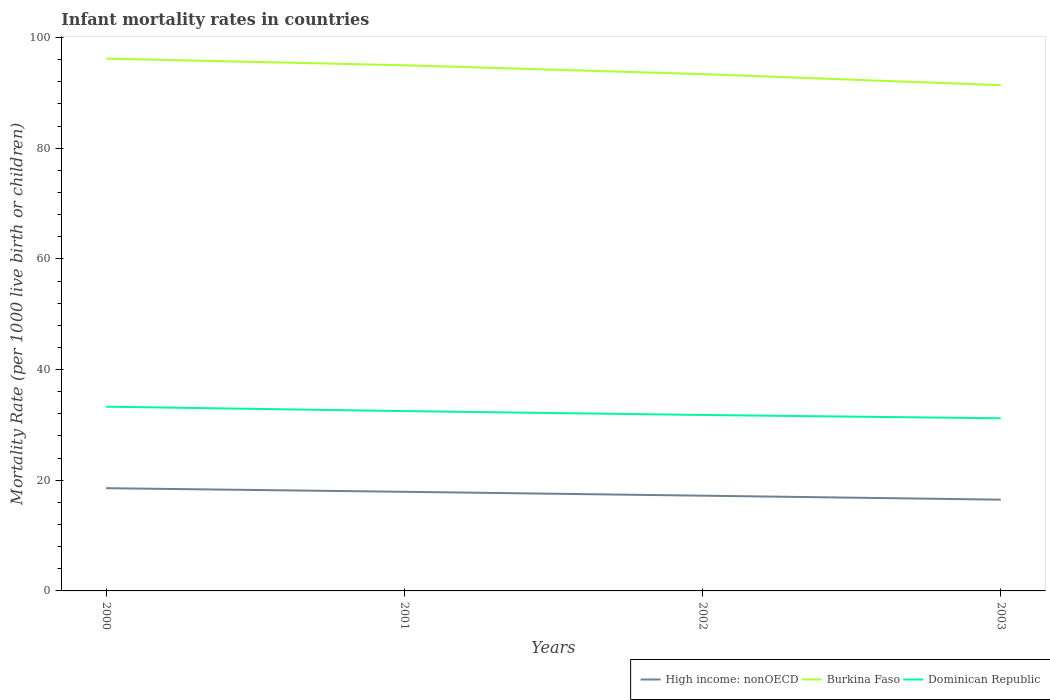How many different coloured lines are there?
Provide a succinct answer. 3. Is the number of lines equal to the number of legend labels?
Your response must be concise. Yes. Across all years, what is the maximum infant mortality rate in Dominican Republic?
Give a very brief answer. 31.2. In which year was the infant mortality rate in High income: nonOECD maximum?
Your answer should be very brief. 2003. What is the total infant mortality rate in Dominican Republic in the graph?
Keep it short and to the point. 1.3. What is the difference between the highest and the second highest infant mortality rate in High income: nonOECD?
Provide a short and direct response. 2.07. Where does the legend appear in the graph?
Provide a short and direct response. Bottom right. How many legend labels are there?
Offer a terse response. 3. How are the legend labels stacked?
Your answer should be compact. Horizontal. What is the title of the graph?
Your answer should be compact. Infant mortality rates in countries. Does "Europe(all income levels)" appear as one of the legend labels in the graph?
Your response must be concise. No. What is the label or title of the X-axis?
Your response must be concise. Years. What is the label or title of the Y-axis?
Your response must be concise. Mortality Rate (per 1000 live birth or children). What is the Mortality Rate (per 1000 live birth or children) in High income: nonOECD in 2000?
Make the answer very short. 18.57. What is the Mortality Rate (per 1000 live birth or children) of Burkina Faso in 2000?
Provide a succinct answer. 96.2. What is the Mortality Rate (per 1000 live birth or children) of Dominican Republic in 2000?
Make the answer very short. 33.3. What is the Mortality Rate (per 1000 live birth or children) of High income: nonOECD in 2001?
Offer a very short reply. 17.92. What is the Mortality Rate (per 1000 live birth or children) in Burkina Faso in 2001?
Ensure brevity in your answer.  95. What is the Mortality Rate (per 1000 live birth or children) in Dominican Republic in 2001?
Offer a very short reply. 32.5. What is the Mortality Rate (per 1000 live birth or children) of High income: nonOECD in 2002?
Offer a very short reply. 17.21. What is the Mortality Rate (per 1000 live birth or children) of Burkina Faso in 2002?
Give a very brief answer. 93.4. What is the Mortality Rate (per 1000 live birth or children) in Dominican Republic in 2002?
Provide a succinct answer. 31.8. What is the Mortality Rate (per 1000 live birth or children) of High income: nonOECD in 2003?
Your answer should be very brief. 16.49. What is the Mortality Rate (per 1000 live birth or children) in Burkina Faso in 2003?
Your answer should be very brief. 91.4. What is the Mortality Rate (per 1000 live birth or children) in Dominican Republic in 2003?
Keep it short and to the point. 31.2. Across all years, what is the maximum Mortality Rate (per 1000 live birth or children) of High income: nonOECD?
Offer a very short reply. 18.57. Across all years, what is the maximum Mortality Rate (per 1000 live birth or children) of Burkina Faso?
Provide a short and direct response. 96.2. Across all years, what is the maximum Mortality Rate (per 1000 live birth or children) in Dominican Republic?
Offer a terse response. 33.3. Across all years, what is the minimum Mortality Rate (per 1000 live birth or children) of High income: nonOECD?
Give a very brief answer. 16.49. Across all years, what is the minimum Mortality Rate (per 1000 live birth or children) in Burkina Faso?
Give a very brief answer. 91.4. Across all years, what is the minimum Mortality Rate (per 1000 live birth or children) of Dominican Republic?
Your response must be concise. 31.2. What is the total Mortality Rate (per 1000 live birth or children) of High income: nonOECD in the graph?
Provide a short and direct response. 70.19. What is the total Mortality Rate (per 1000 live birth or children) in Burkina Faso in the graph?
Ensure brevity in your answer.  376. What is the total Mortality Rate (per 1000 live birth or children) in Dominican Republic in the graph?
Offer a very short reply. 128.8. What is the difference between the Mortality Rate (per 1000 live birth or children) in High income: nonOECD in 2000 and that in 2001?
Provide a short and direct response. 0.65. What is the difference between the Mortality Rate (per 1000 live birth or children) of Dominican Republic in 2000 and that in 2001?
Provide a short and direct response. 0.8. What is the difference between the Mortality Rate (per 1000 live birth or children) of High income: nonOECD in 2000 and that in 2002?
Give a very brief answer. 1.35. What is the difference between the Mortality Rate (per 1000 live birth or children) in Burkina Faso in 2000 and that in 2002?
Give a very brief answer. 2.8. What is the difference between the Mortality Rate (per 1000 live birth or children) of Dominican Republic in 2000 and that in 2002?
Your answer should be very brief. 1.5. What is the difference between the Mortality Rate (per 1000 live birth or children) of High income: nonOECD in 2000 and that in 2003?
Give a very brief answer. 2.07. What is the difference between the Mortality Rate (per 1000 live birth or children) of Burkina Faso in 2000 and that in 2003?
Your response must be concise. 4.8. What is the difference between the Mortality Rate (per 1000 live birth or children) of Dominican Republic in 2000 and that in 2003?
Give a very brief answer. 2.1. What is the difference between the Mortality Rate (per 1000 live birth or children) of High income: nonOECD in 2001 and that in 2002?
Provide a succinct answer. 0.7. What is the difference between the Mortality Rate (per 1000 live birth or children) in Burkina Faso in 2001 and that in 2002?
Offer a very short reply. 1.6. What is the difference between the Mortality Rate (per 1000 live birth or children) of Dominican Republic in 2001 and that in 2002?
Give a very brief answer. 0.7. What is the difference between the Mortality Rate (per 1000 live birth or children) of High income: nonOECD in 2001 and that in 2003?
Ensure brevity in your answer.  1.42. What is the difference between the Mortality Rate (per 1000 live birth or children) in Dominican Republic in 2001 and that in 2003?
Offer a terse response. 1.3. What is the difference between the Mortality Rate (per 1000 live birth or children) in High income: nonOECD in 2002 and that in 2003?
Your response must be concise. 0.72. What is the difference between the Mortality Rate (per 1000 live birth or children) in Dominican Republic in 2002 and that in 2003?
Your answer should be very brief. 0.6. What is the difference between the Mortality Rate (per 1000 live birth or children) in High income: nonOECD in 2000 and the Mortality Rate (per 1000 live birth or children) in Burkina Faso in 2001?
Give a very brief answer. -76.43. What is the difference between the Mortality Rate (per 1000 live birth or children) in High income: nonOECD in 2000 and the Mortality Rate (per 1000 live birth or children) in Dominican Republic in 2001?
Keep it short and to the point. -13.93. What is the difference between the Mortality Rate (per 1000 live birth or children) in Burkina Faso in 2000 and the Mortality Rate (per 1000 live birth or children) in Dominican Republic in 2001?
Offer a very short reply. 63.7. What is the difference between the Mortality Rate (per 1000 live birth or children) in High income: nonOECD in 2000 and the Mortality Rate (per 1000 live birth or children) in Burkina Faso in 2002?
Your response must be concise. -74.83. What is the difference between the Mortality Rate (per 1000 live birth or children) of High income: nonOECD in 2000 and the Mortality Rate (per 1000 live birth or children) of Dominican Republic in 2002?
Provide a succinct answer. -13.23. What is the difference between the Mortality Rate (per 1000 live birth or children) in Burkina Faso in 2000 and the Mortality Rate (per 1000 live birth or children) in Dominican Republic in 2002?
Your response must be concise. 64.4. What is the difference between the Mortality Rate (per 1000 live birth or children) of High income: nonOECD in 2000 and the Mortality Rate (per 1000 live birth or children) of Burkina Faso in 2003?
Make the answer very short. -72.83. What is the difference between the Mortality Rate (per 1000 live birth or children) of High income: nonOECD in 2000 and the Mortality Rate (per 1000 live birth or children) of Dominican Republic in 2003?
Your response must be concise. -12.63. What is the difference between the Mortality Rate (per 1000 live birth or children) of Burkina Faso in 2000 and the Mortality Rate (per 1000 live birth or children) of Dominican Republic in 2003?
Your response must be concise. 65. What is the difference between the Mortality Rate (per 1000 live birth or children) in High income: nonOECD in 2001 and the Mortality Rate (per 1000 live birth or children) in Burkina Faso in 2002?
Keep it short and to the point. -75.48. What is the difference between the Mortality Rate (per 1000 live birth or children) in High income: nonOECD in 2001 and the Mortality Rate (per 1000 live birth or children) in Dominican Republic in 2002?
Make the answer very short. -13.88. What is the difference between the Mortality Rate (per 1000 live birth or children) of Burkina Faso in 2001 and the Mortality Rate (per 1000 live birth or children) of Dominican Republic in 2002?
Your answer should be compact. 63.2. What is the difference between the Mortality Rate (per 1000 live birth or children) of High income: nonOECD in 2001 and the Mortality Rate (per 1000 live birth or children) of Burkina Faso in 2003?
Your answer should be compact. -73.48. What is the difference between the Mortality Rate (per 1000 live birth or children) of High income: nonOECD in 2001 and the Mortality Rate (per 1000 live birth or children) of Dominican Republic in 2003?
Provide a succinct answer. -13.28. What is the difference between the Mortality Rate (per 1000 live birth or children) in Burkina Faso in 2001 and the Mortality Rate (per 1000 live birth or children) in Dominican Republic in 2003?
Your response must be concise. 63.8. What is the difference between the Mortality Rate (per 1000 live birth or children) in High income: nonOECD in 2002 and the Mortality Rate (per 1000 live birth or children) in Burkina Faso in 2003?
Make the answer very short. -74.19. What is the difference between the Mortality Rate (per 1000 live birth or children) in High income: nonOECD in 2002 and the Mortality Rate (per 1000 live birth or children) in Dominican Republic in 2003?
Your response must be concise. -13.99. What is the difference between the Mortality Rate (per 1000 live birth or children) of Burkina Faso in 2002 and the Mortality Rate (per 1000 live birth or children) of Dominican Republic in 2003?
Your answer should be compact. 62.2. What is the average Mortality Rate (per 1000 live birth or children) in High income: nonOECD per year?
Offer a very short reply. 17.55. What is the average Mortality Rate (per 1000 live birth or children) in Burkina Faso per year?
Provide a succinct answer. 94. What is the average Mortality Rate (per 1000 live birth or children) of Dominican Republic per year?
Offer a terse response. 32.2. In the year 2000, what is the difference between the Mortality Rate (per 1000 live birth or children) of High income: nonOECD and Mortality Rate (per 1000 live birth or children) of Burkina Faso?
Your response must be concise. -77.63. In the year 2000, what is the difference between the Mortality Rate (per 1000 live birth or children) in High income: nonOECD and Mortality Rate (per 1000 live birth or children) in Dominican Republic?
Provide a succinct answer. -14.73. In the year 2000, what is the difference between the Mortality Rate (per 1000 live birth or children) in Burkina Faso and Mortality Rate (per 1000 live birth or children) in Dominican Republic?
Provide a succinct answer. 62.9. In the year 2001, what is the difference between the Mortality Rate (per 1000 live birth or children) of High income: nonOECD and Mortality Rate (per 1000 live birth or children) of Burkina Faso?
Your response must be concise. -77.08. In the year 2001, what is the difference between the Mortality Rate (per 1000 live birth or children) of High income: nonOECD and Mortality Rate (per 1000 live birth or children) of Dominican Republic?
Provide a short and direct response. -14.58. In the year 2001, what is the difference between the Mortality Rate (per 1000 live birth or children) in Burkina Faso and Mortality Rate (per 1000 live birth or children) in Dominican Republic?
Keep it short and to the point. 62.5. In the year 2002, what is the difference between the Mortality Rate (per 1000 live birth or children) of High income: nonOECD and Mortality Rate (per 1000 live birth or children) of Burkina Faso?
Offer a terse response. -76.19. In the year 2002, what is the difference between the Mortality Rate (per 1000 live birth or children) of High income: nonOECD and Mortality Rate (per 1000 live birth or children) of Dominican Republic?
Provide a succinct answer. -14.59. In the year 2002, what is the difference between the Mortality Rate (per 1000 live birth or children) in Burkina Faso and Mortality Rate (per 1000 live birth or children) in Dominican Republic?
Your answer should be compact. 61.6. In the year 2003, what is the difference between the Mortality Rate (per 1000 live birth or children) in High income: nonOECD and Mortality Rate (per 1000 live birth or children) in Burkina Faso?
Make the answer very short. -74.91. In the year 2003, what is the difference between the Mortality Rate (per 1000 live birth or children) in High income: nonOECD and Mortality Rate (per 1000 live birth or children) in Dominican Republic?
Keep it short and to the point. -14.71. In the year 2003, what is the difference between the Mortality Rate (per 1000 live birth or children) of Burkina Faso and Mortality Rate (per 1000 live birth or children) of Dominican Republic?
Offer a terse response. 60.2. What is the ratio of the Mortality Rate (per 1000 live birth or children) of High income: nonOECD in 2000 to that in 2001?
Your answer should be very brief. 1.04. What is the ratio of the Mortality Rate (per 1000 live birth or children) of Burkina Faso in 2000 to that in 2001?
Provide a short and direct response. 1.01. What is the ratio of the Mortality Rate (per 1000 live birth or children) in Dominican Republic in 2000 to that in 2001?
Your response must be concise. 1.02. What is the ratio of the Mortality Rate (per 1000 live birth or children) in High income: nonOECD in 2000 to that in 2002?
Your answer should be compact. 1.08. What is the ratio of the Mortality Rate (per 1000 live birth or children) of Burkina Faso in 2000 to that in 2002?
Provide a short and direct response. 1.03. What is the ratio of the Mortality Rate (per 1000 live birth or children) of Dominican Republic in 2000 to that in 2002?
Make the answer very short. 1.05. What is the ratio of the Mortality Rate (per 1000 live birth or children) of High income: nonOECD in 2000 to that in 2003?
Give a very brief answer. 1.13. What is the ratio of the Mortality Rate (per 1000 live birth or children) in Burkina Faso in 2000 to that in 2003?
Offer a terse response. 1.05. What is the ratio of the Mortality Rate (per 1000 live birth or children) in Dominican Republic in 2000 to that in 2003?
Keep it short and to the point. 1.07. What is the ratio of the Mortality Rate (per 1000 live birth or children) in High income: nonOECD in 2001 to that in 2002?
Ensure brevity in your answer.  1.04. What is the ratio of the Mortality Rate (per 1000 live birth or children) of Burkina Faso in 2001 to that in 2002?
Ensure brevity in your answer.  1.02. What is the ratio of the Mortality Rate (per 1000 live birth or children) in High income: nonOECD in 2001 to that in 2003?
Keep it short and to the point. 1.09. What is the ratio of the Mortality Rate (per 1000 live birth or children) of Burkina Faso in 2001 to that in 2003?
Provide a short and direct response. 1.04. What is the ratio of the Mortality Rate (per 1000 live birth or children) of Dominican Republic in 2001 to that in 2003?
Provide a succinct answer. 1.04. What is the ratio of the Mortality Rate (per 1000 live birth or children) of High income: nonOECD in 2002 to that in 2003?
Offer a very short reply. 1.04. What is the ratio of the Mortality Rate (per 1000 live birth or children) in Burkina Faso in 2002 to that in 2003?
Your response must be concise. 1.02. What is the ratio of the Mortality Rate (per 1000 live birth or children) of Dominican Republic in 2002 to that in 2003?
Provide a short and direct response. 1.02. What is the difference between the highest and the second highest Mortality Rate (per 1000 live birth or children) of High income: nonOECD?
Provide a succinct answer. 0.65. What is the difference between the highest and the second highest Mortality Rate (per 1000 live birth or children) of Burkina Faso?
Offer a terse response. 1.2. What is the difference between the highest and the second highest Mortality Rate (per 1000 live birth or children) in Dominican Republic?
Make the answer very short. 0.8. What is the difference between the highest and the lowest Mortality Rate (per 1000 live birth or children) of High income: nonOECD?
Provide a short and direct response. 2.07. What is the difference between the highest and the lowest Mortality Rate (per 1000 live birth or children) of Burkina Faso?
Give a very brief answer. 4.8. What is the difference between the highest and the lowest Mortality Rate (per 1000 live birth or children) of Dominican Republic?
Keep it short and to the point. 2.1. 